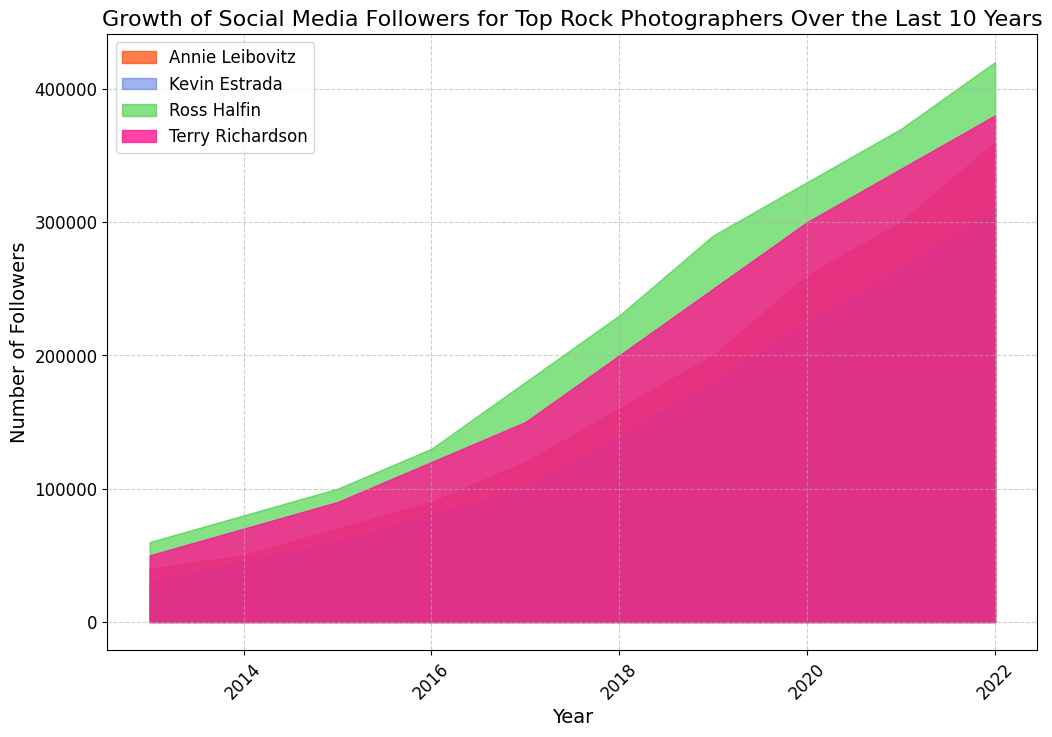what's the average number of followers for Terry Richardson in the first 5 years? First, take Terry Richardson's followers for 2013 to 2017: (50,000, 70,000, 90,000, 120,000, 150,000). Sum these numbers: 50,000 + 70,000 + 90,000 + 120,000 + 150,000 = 480,000. Then divide by 5 to get the average: 480,000 / 5 = 96,000
Answer: 96,000 Which photographer had the highest number of followers in 2022? Look at the followers for each photographer in 2022: Terry Richardson (380,000), Annie Leibovitz (360,000), Ross Halfin (420,000), Kevin Estrada (310,000). Ross Halfin has the highest number of followers.
Answer: Ross Halfin Between Annie Leibovitz and Kevin Estrada, who had a higher growth in followers from 2013 to 2022? Calculate the growth for each from 2013 to 2022. Annie Leibovitz: 360,000 - 40,000 = 320,000. Kevin Estrada: 310,000 - 30,000 = 280,000. Annie Leibovitz had a higher growth.
Answer: Annie Leibovitz In which year did Ross Halfin's followers reach 230,000? From the data, seeing the growth of Ross Halfin's followers: 2018 (230,000).
Answer: 2018 What's the difference in followers between Terry Richardson and Annie Leibovitz in 2021? Terry Richardson's followers in 2021: 340,000. Annie Leibovitz's followers in 2021: 300,000. The difference: 340,000 - 300,000 = 40,000.
Answer: 40,000 How many followers did Kevin Estrada gain between 2015 and 2019? Kevin Estrada's followers in 2015: 60,000. In 2019: 180,000. The gain: 180,000 - 60,000 = 120,000.
Answer: 120,000 Which photographer had their biggest single-year growth in followers between 2017 and 2018? Calculate single-year growth for each from 2017 to 2018. Terry Richardson: 200,000 - 150,000 = 50,000. Annie Leibovitz: 160,000 - 120,000 = 40,000. Ross Halfin: 230,000 - 180,000 = 50,000. Kevin Estrada: 140,000 - 100,000 = 40,000. Both Terry Richardson and Ross Halfin had the biggest growth of 50,000 followers.
Answer: Terry Richardson and Ross Halfin 